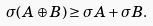<formula> <loc_0><loc_0><loc_500><loc_500>\sigma ( A \oplus B ) \geq \sigma A + \sigma B .</formula> 